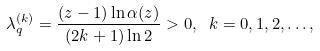<formula> <loc_0><loc_0><loc_500><loc_500>\lambda _ { q } ^ { ( k ) } = \frac { ( z - 1 ) \ln \alpha ( z ) } { ( 2 k + 1 ) \ln 2 } > 0 , \ k = 0 , 1 , 2 , \dots ,</formula> 